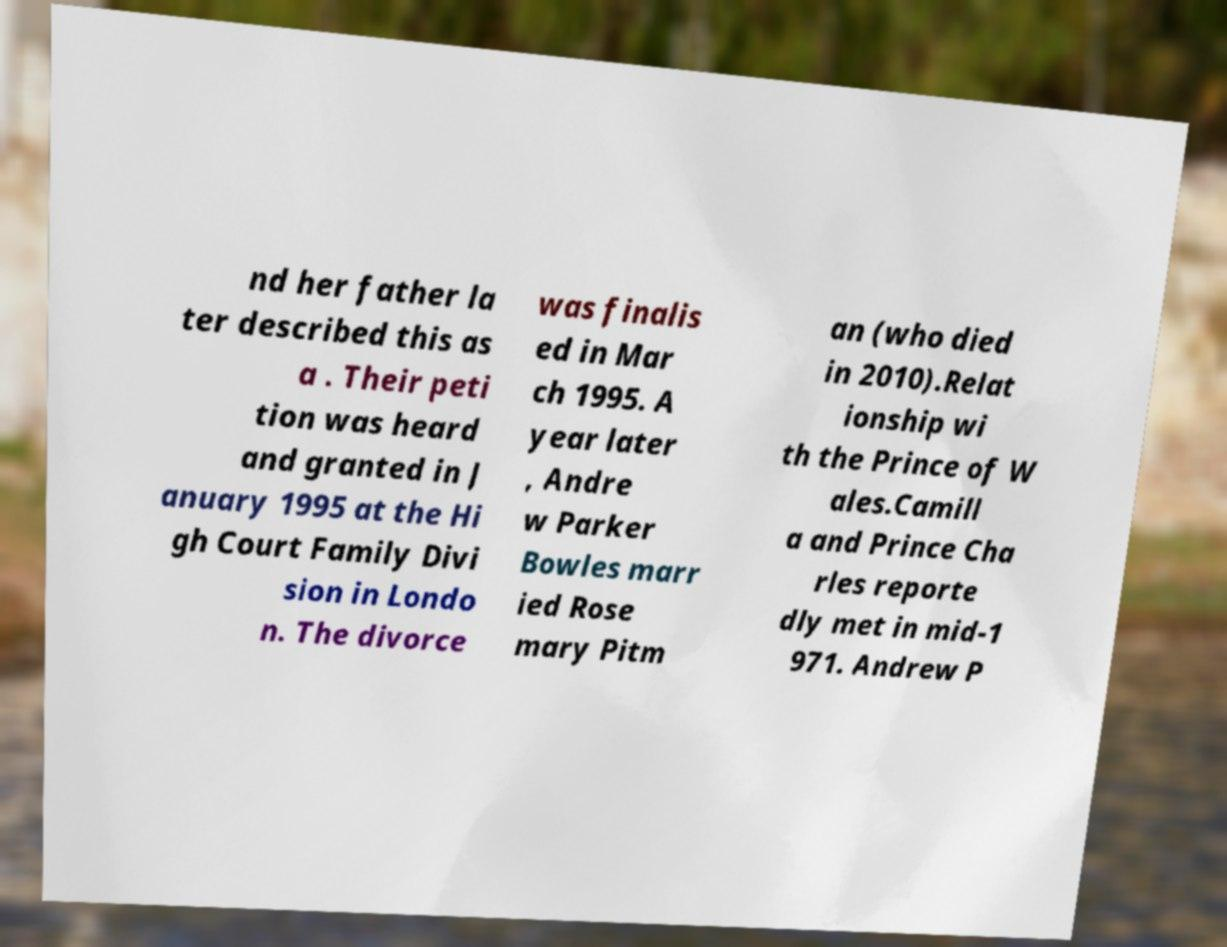What messages or text are displayed in this image? I need them in a readable, typed format. nd her father la ter described this as a . Their peti tion was heard and granted in J anuary 1995 at the Hi gh Court Family Divi sion in Londo n. The divorce was finalis ed in Mar ch 1995. A year later , Andre w Parker Bowles marr ied Rose mary Pitm an (who died in 2010).Relat ionship wi th the Prince of W ales.Camill a and Prince Cha rles reporte dly met in mid-1 971. Andrew P 